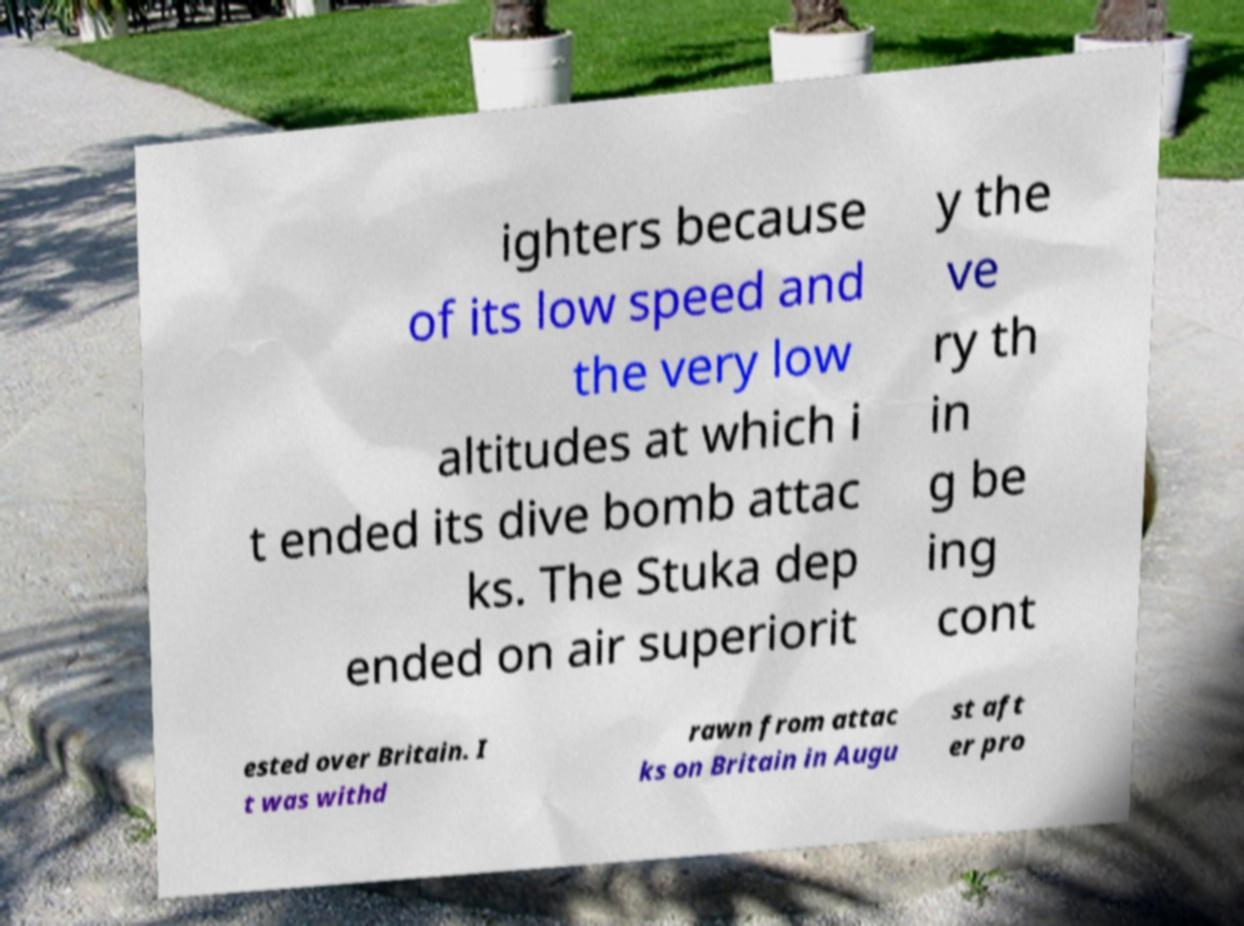Could you extract and type out the text from this image? ighters because of its low speed and the very low altitudes at which i t ended its dive bomb attac ks. The Stuka dep ended on air superiorit y the ve ry th in g be ing cont ested over Britain. I t was withd rawn from attac ks on Britain in Augu st aft er pro 